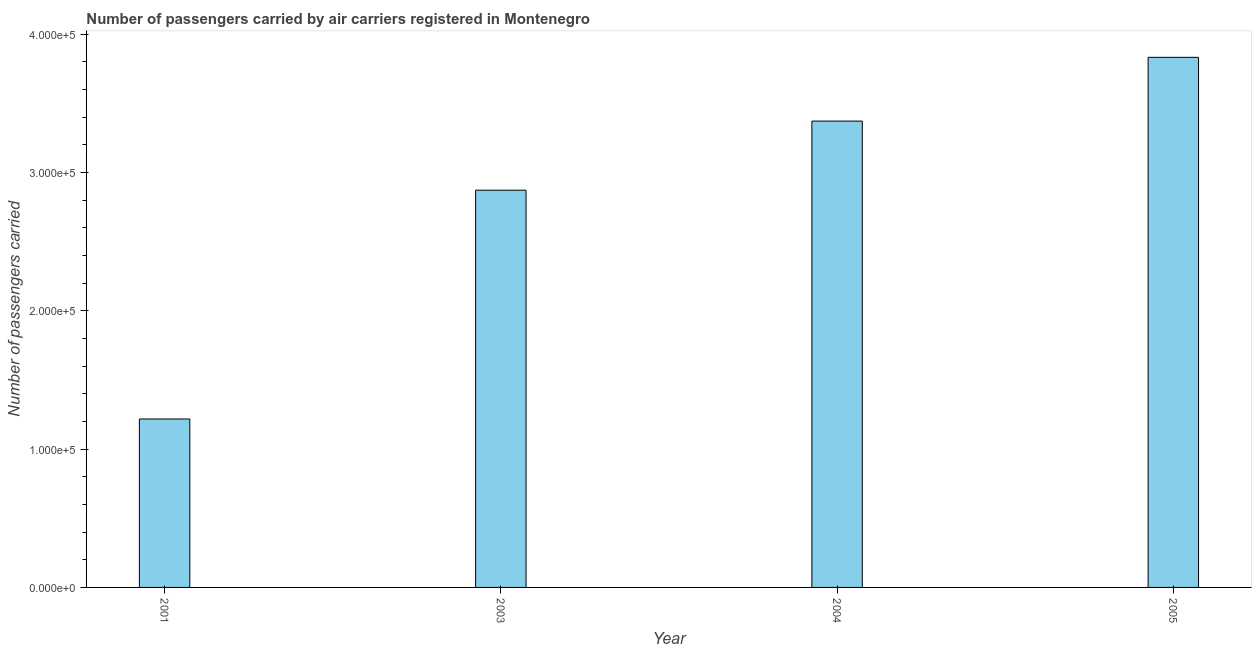Does the graph contain grids?
Give a very brief answer. No. What is the title of the graph?
Provide a succinct answer. Number of passengers carried by air carriers registered in Montenegro. What is the label or title of the X-axis?
Provide a short and direct response. Year. What is the label or title of the Y-axis?
Provide a short and direct response. Number of passengers carried. What is the number of passengers carried in 2004?
Provide a short and direct response. 3.37e+05. Across all years, what is the maximum number of passengers carried?
Offer a very short reply. 3.83e+05. Across all years, what is the minimum number of passengers carried?
Provide a succinct answer. 1.22e+05. What is the sum of the number of passengers carried?
Offer a terse response. 1.13e+06. What is the difference between the number of passengers carried in 2003 and 2005?
Provide a succinct answer. -9.60e+04. What is the average number of passengers carried per year?
Make the answer very short. 2.82e+05. What is the median number of passengers carried?
Keep it short and to the point. 3.12e+05. What is the ratio of the number of passengers carried in 2003 to that in 2005?
Your response must be concise. 0.75. What is the difference between the highest and the second highest number of passengers carried?
Keep it short and to the point. 4.61e+04. What is the difference between the highest and the lowest number of passengers carried?
Your answer should be very brief. 2.61e+05. How many bars are there?
Give a very brief answer. 4. What is the Number of passengers carried of 2001?
Offer a very short reply. 1.22e+05. What is the Number of passengers carried in 2003?
Provide a short and direct response. 2.87e+05. What is the Number of passengers carried in 2004?
Give a very brief answer. 3.37e+05. What is the Number of passengers carried of 2005?
Provide a succinct answer. 3.83e+05. What is the difference between the Number of passengers carried in 2001 and 2003?
Your response must be concise. -1.65e+05. What is the difference between the Number of passengers carried in 2001 and 2004?
Ensure brevity in your answer.  -2.15e+05. What is the difference between the Number of passengers carried in 2001 and 2005?
Offer a very short reply. -2.61e+05. What is the difference between the Number of passengers carried in 2003 and 2004?
Your answer should be compact. -4.99e+04. What is the difference between the Number of passengers carried in 2003 and 2005?
Your answer should be compact. -9.60e+04. What is the difference between the Number of passengers carried in 2004 and 2005?
Offer a terse response. -4.61e+04. What is the ratio of the Number of passengers carried in 2001 to that in 2003?
Ensure brevity in your answer.  0.42. What is the ratio of the Number of passengers carried in 2001 to that in 2004?
Provide a succinct answer. 0.36. What is the ratio of the Number of passengers carried in 2001 to that in 2005?
Make the answer very short. 0.32. What is the ratio of the Number of passengers carried in 2003 to that in 2004?
Provide a short and direct response. 0.85. What is the ratio of the Number of passengers carried in 2003 to that in 2005?
Keep it short and to the point. 0.75. 